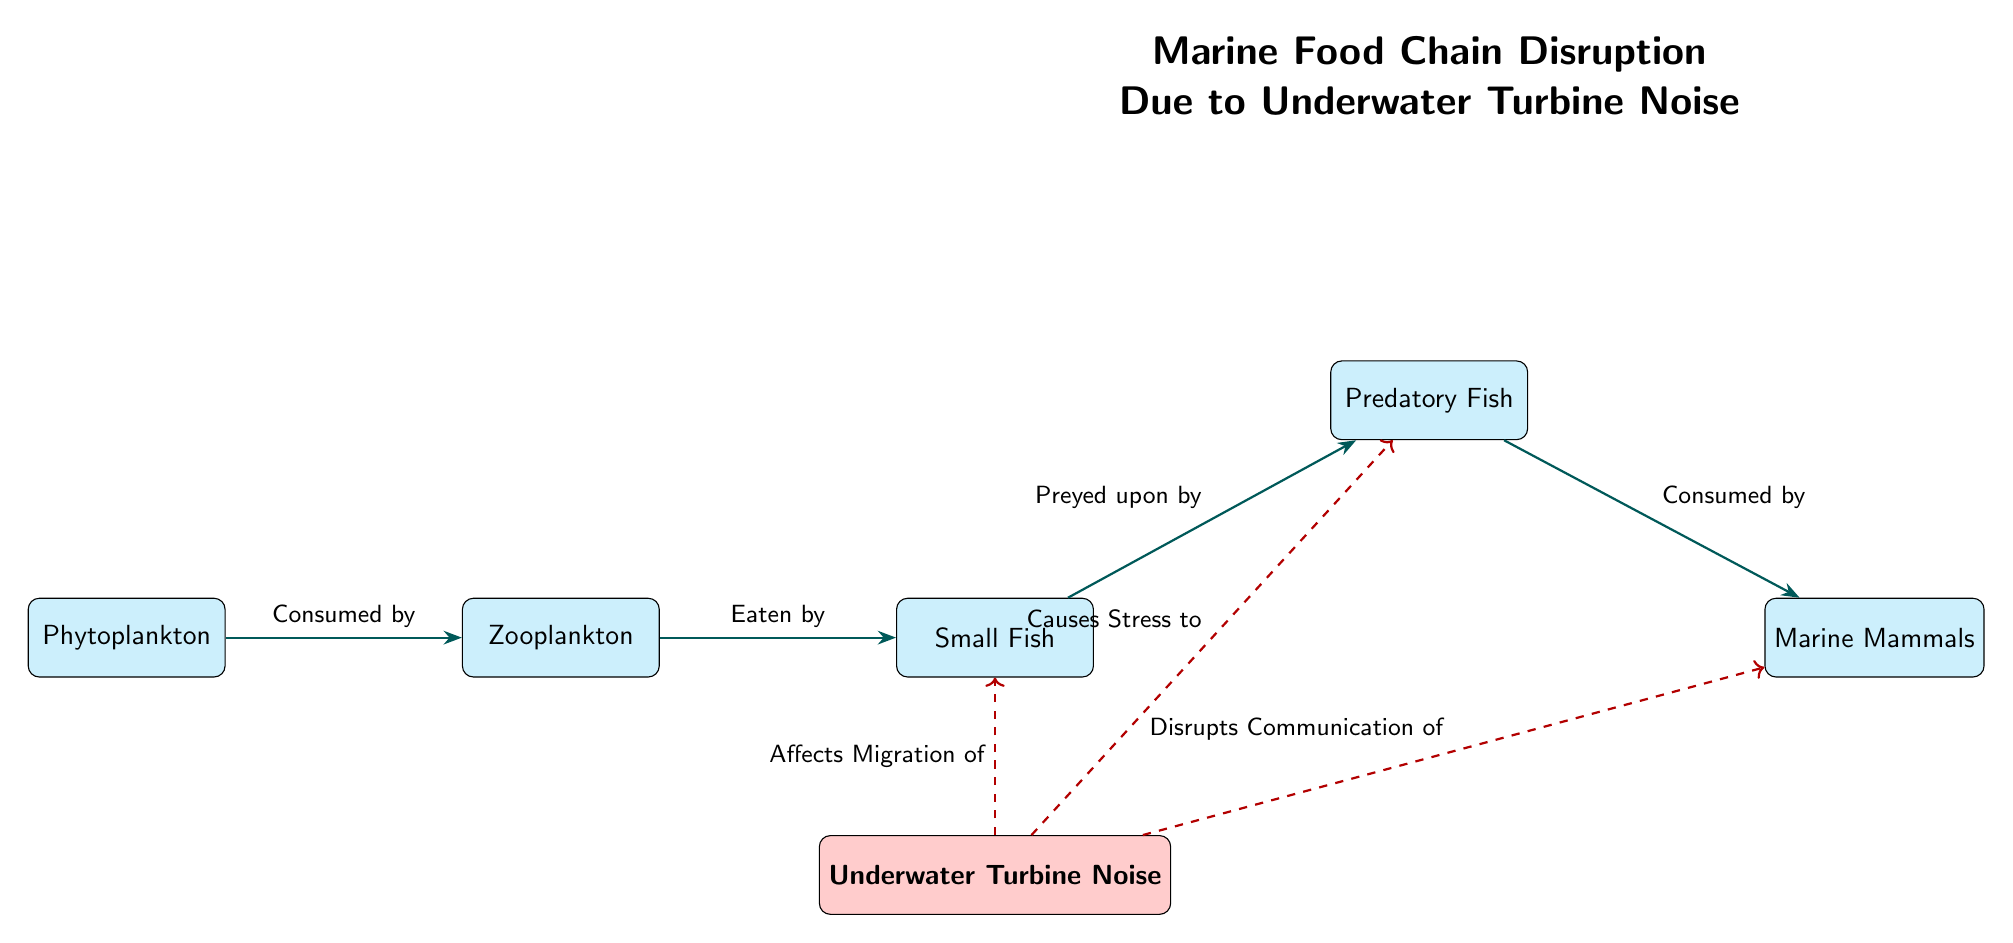What's the primary producer in the diagram? The primary producer is the first node in the food chain, which is phytoplankton, as it is the base of the marine food web.
Answer: Phytoplankton How many species are depicted in the food chain? Counting the nodes within the food chain section, there are five species: phytoplankton, zooplankton, small fish, predatory fish, and marine mammals.
Answer: Five What relationship exists between small fish and predatory fish? The relationship is indicated by an arrow labeled "Preyed upon by," showing that predatory fish consume small fish in the food chain.
Answer: Preyed upon by Which species is affected by underwater turbine noise, causing stress? The diagram shows a dashed line from the underwater turbine to predatory fish, indicating that the turbine noise causes stress to this species.
Answer: Predatory Fish How many effects are shown resulting from underwater turbine noise? There are three distinct effects illustrated with arrows leading from the underwater turbine to other nodes, indicating the different impacts of the noise.
Answer: Three What is the impact of underwater turbine noise on small fish? The impact is detailed with an arrow indicating that the turbine affects the migration of small fish, suggesting a disruption in their movement patterns due to noise.
Answer: Affects Migration Which species has disrupted communication due to underwater turbine noise? The dashed line connects the underwater turbine to marine mammals, indicating that their communication is disrupted by the noise, affecting their survival and interactions.
Answer: Marine Mammals Name the top predator in the food chain. The top predator can be identified as the last species in the food chain, which is marine mammals, as they are at the apex of this specific food web.
Answer: Marine Mammals What color represents the underwater turbine in the diagram? The underwater turbine is represented in red color, distinguishing it from the species nodes, which are shown in cyan.
Answer: Red 